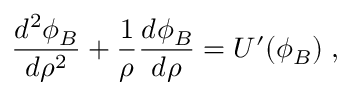Convert formula to latex. <formula><loc_0><loc_0><loc_500><loc_500>\frac { d ^ { 2 } \phi _ { B } } { d \rho ^ { 2 } } + \frac { 1 } { \rho } \frac { d \phi _ { B } } { d \rho } = U ^ { \prime } ( \phi _ { B } ) \, ,</formula> 